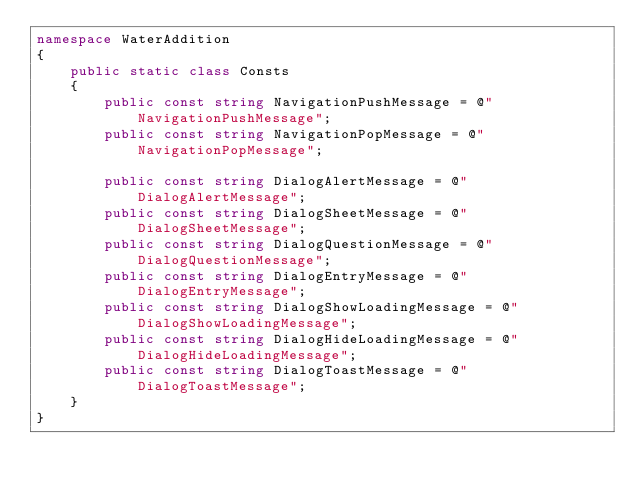Convert code to text. <code><loc_0><loc_0><loc_500><loc_500><_C#_>namespace WaterAddition
{
    public static class Consts
    {
	    public const string NavigationPushMessage = @"NavigationPushMessage";
	    public const string NavigationPopMessage = @"NavigationPopMessage";

	    public const string DialogAlertMessage = @"DialogAlertMessage";
	    public const string DialogSheetMessage = @"DialogSheetMessage";
	    public const string DialogQuestionMessage = @"DialogQuestionMessage";
	    public const string DialogEntryMessage = @"DialogEntryMessage";
	    public const string DialogShowLoadingMessage = @"DialogShowLoadingMessage";
	    public const string DialogHideLoadingMessage = @"DialogHideLoadingMessage";
	    public const string DialogToastMessage = @"DialogToastMessage";
	}
}

</code> 